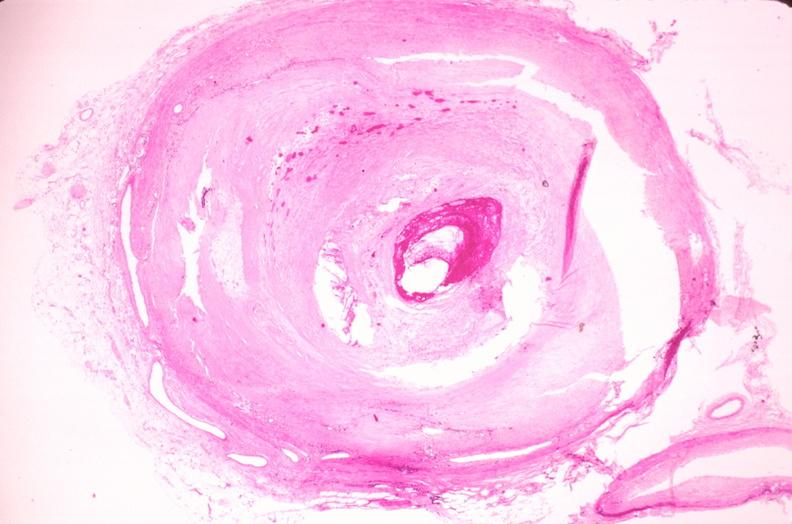s this present?
Answer the question using a single word or phrase. No 